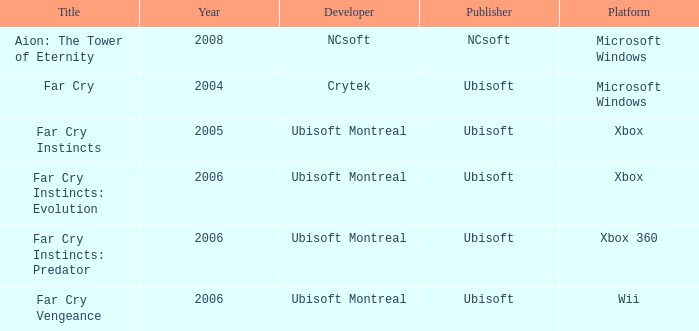Which title has a year prior to 2008 and xbox 360 as the platform? Far Cry Instincts: Predator. 